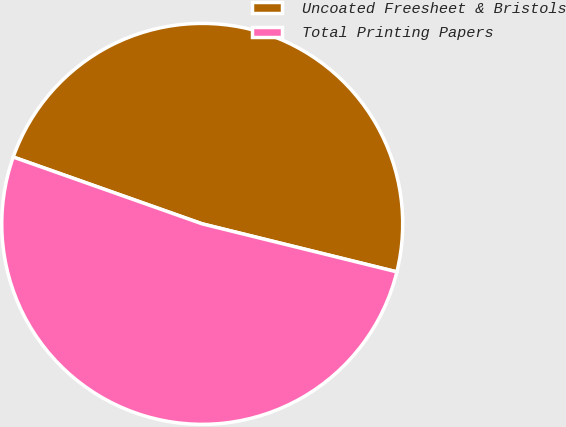Convert chart. <chart><loc_0><loc_0><loc_500><loc_500><pie_chart><fcel>Uncoated Freesheet & Bristols<fcel>Total Printing Papers<nl><fcel>48.44%<fcel>51.56%<nl></chart> 